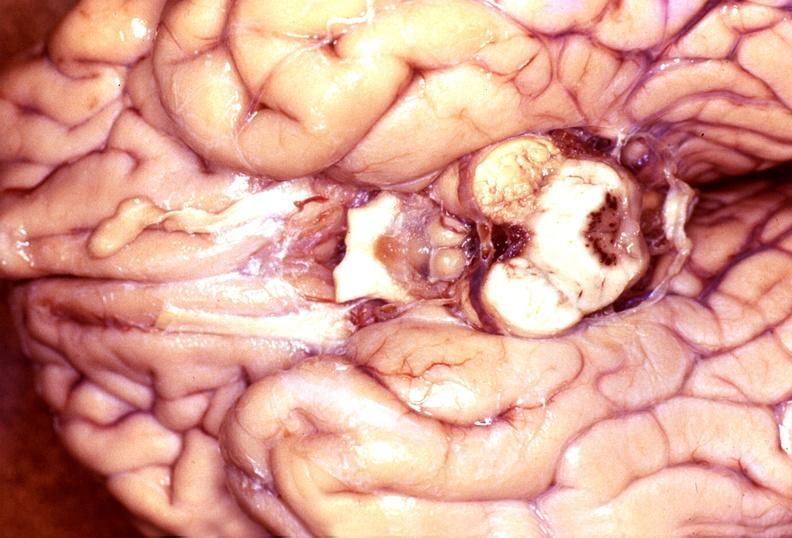does bone, skull show wernicke 's encephalopathy?
Answer the question using a single word or phrase. No 